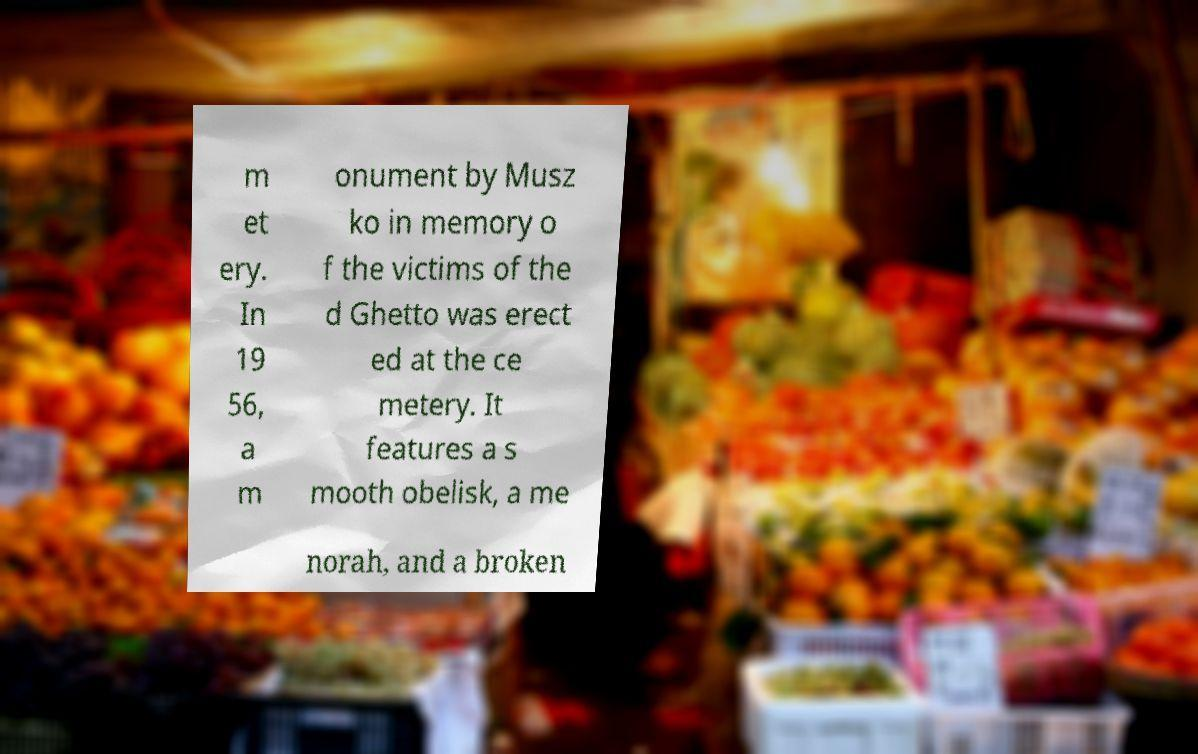Could you extract and type out the text from this image? m et ery. In 19 56, a m onument by Musz ko in memory o f the victims of the d Ghetto was erect ed at the ce metery. It features a s mooth obelisk, a me norah, and a broken 